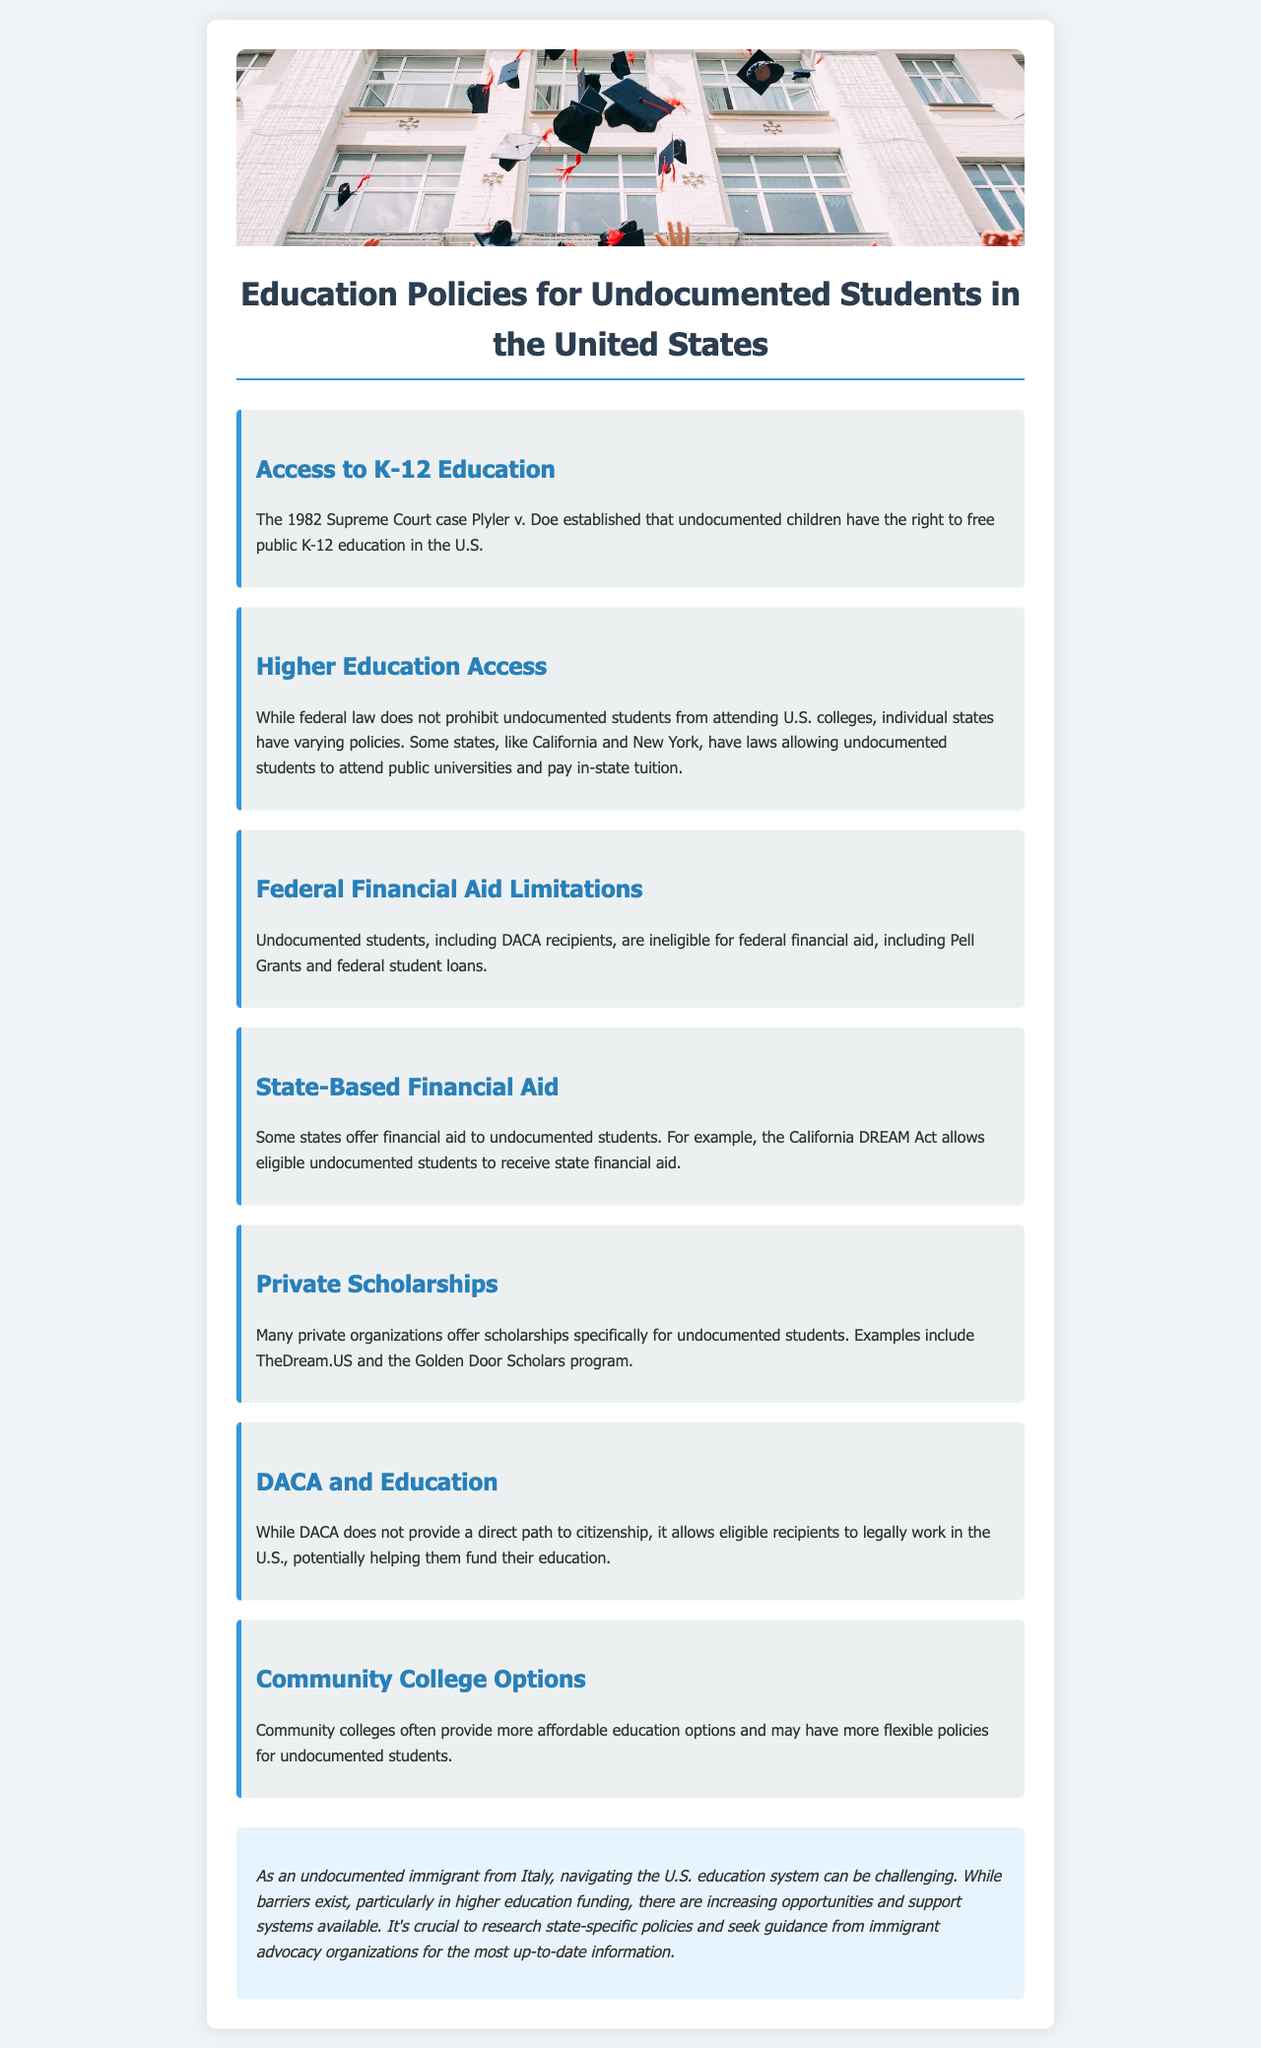What Supreme Court case established the right to K-12 education? The document mentions Plyler v. Doe as the case that established the right to free public K-12 education for undocumented children in the U.S.
Answer: Plyler v. Doe Which two states have laws allowing undocumented students to pay in-state tuition? The document lists California and New York as states where undocumented students can attend public universities and pay in-state tuition.
Answer: California and New York Are undocumented students eligible for federal financial aid? The document states that undocumented students, including DACA recipients, are ineligible for federal financial aid.
Answer: No What act allows eligible undocumented students in California to receive state financial aid? The document refers to the California DREAM Act as the law that allows eligible undocumented students to receive state financial aid.
Answer: California DREAM Act What is one option for more affordable education mentioned for undocumented students? The document highlights community colleges as providing more affordable education options for undocumented students.
Answer: Community colleges How does DACA help with funding education? The document explains that while DACA does not provide a direct path to citizenship, it allows eligible recipients to legally work in the U.S., which can help fund their education.
Answer: Legally work What type of organizations offer scholarships specifically for undocumented students? The document indicates that private organizations provide scholarships aimed at undocumented students.
Answer: Private organizations What is a crucial step for undocumented immigrants to research regarding education? The document emphasizes the importance of researching state-specific policies and seeking guidance from immigrant advocacy organizations.
Answer: State-specific policies 